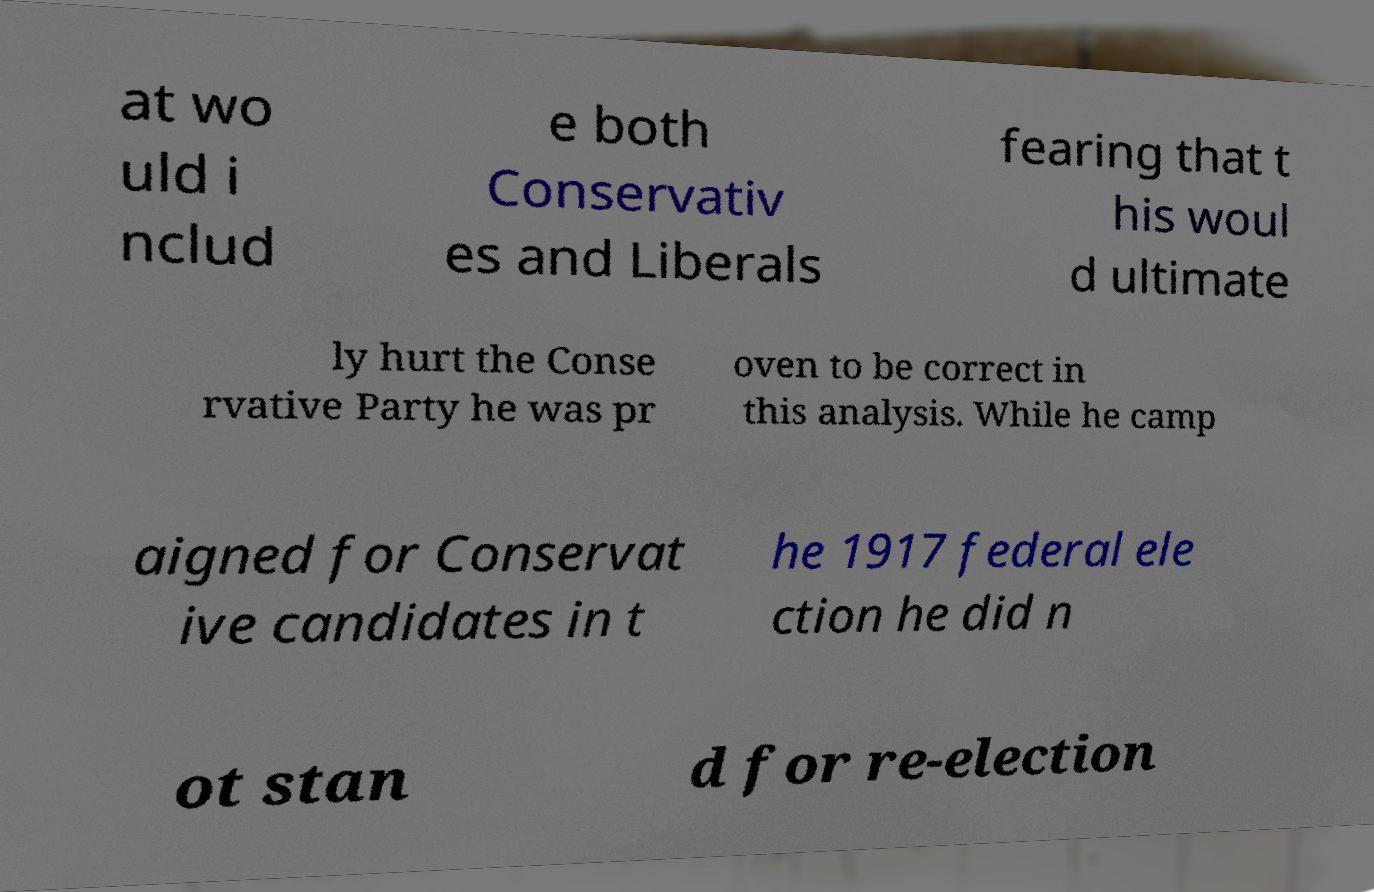Could you assist in decoding the text presented in this image and type it out clearly? at wo uld i nclud e both Conservativ es and Liberals fearing that t his woul d ultimate ly hurt the Conse rvative Party he was pr oven to be correct in this analysis. While he camp aigned for Conservat ive candidates in t he 1917 federal ele ction he did n ot stan d for re-election 